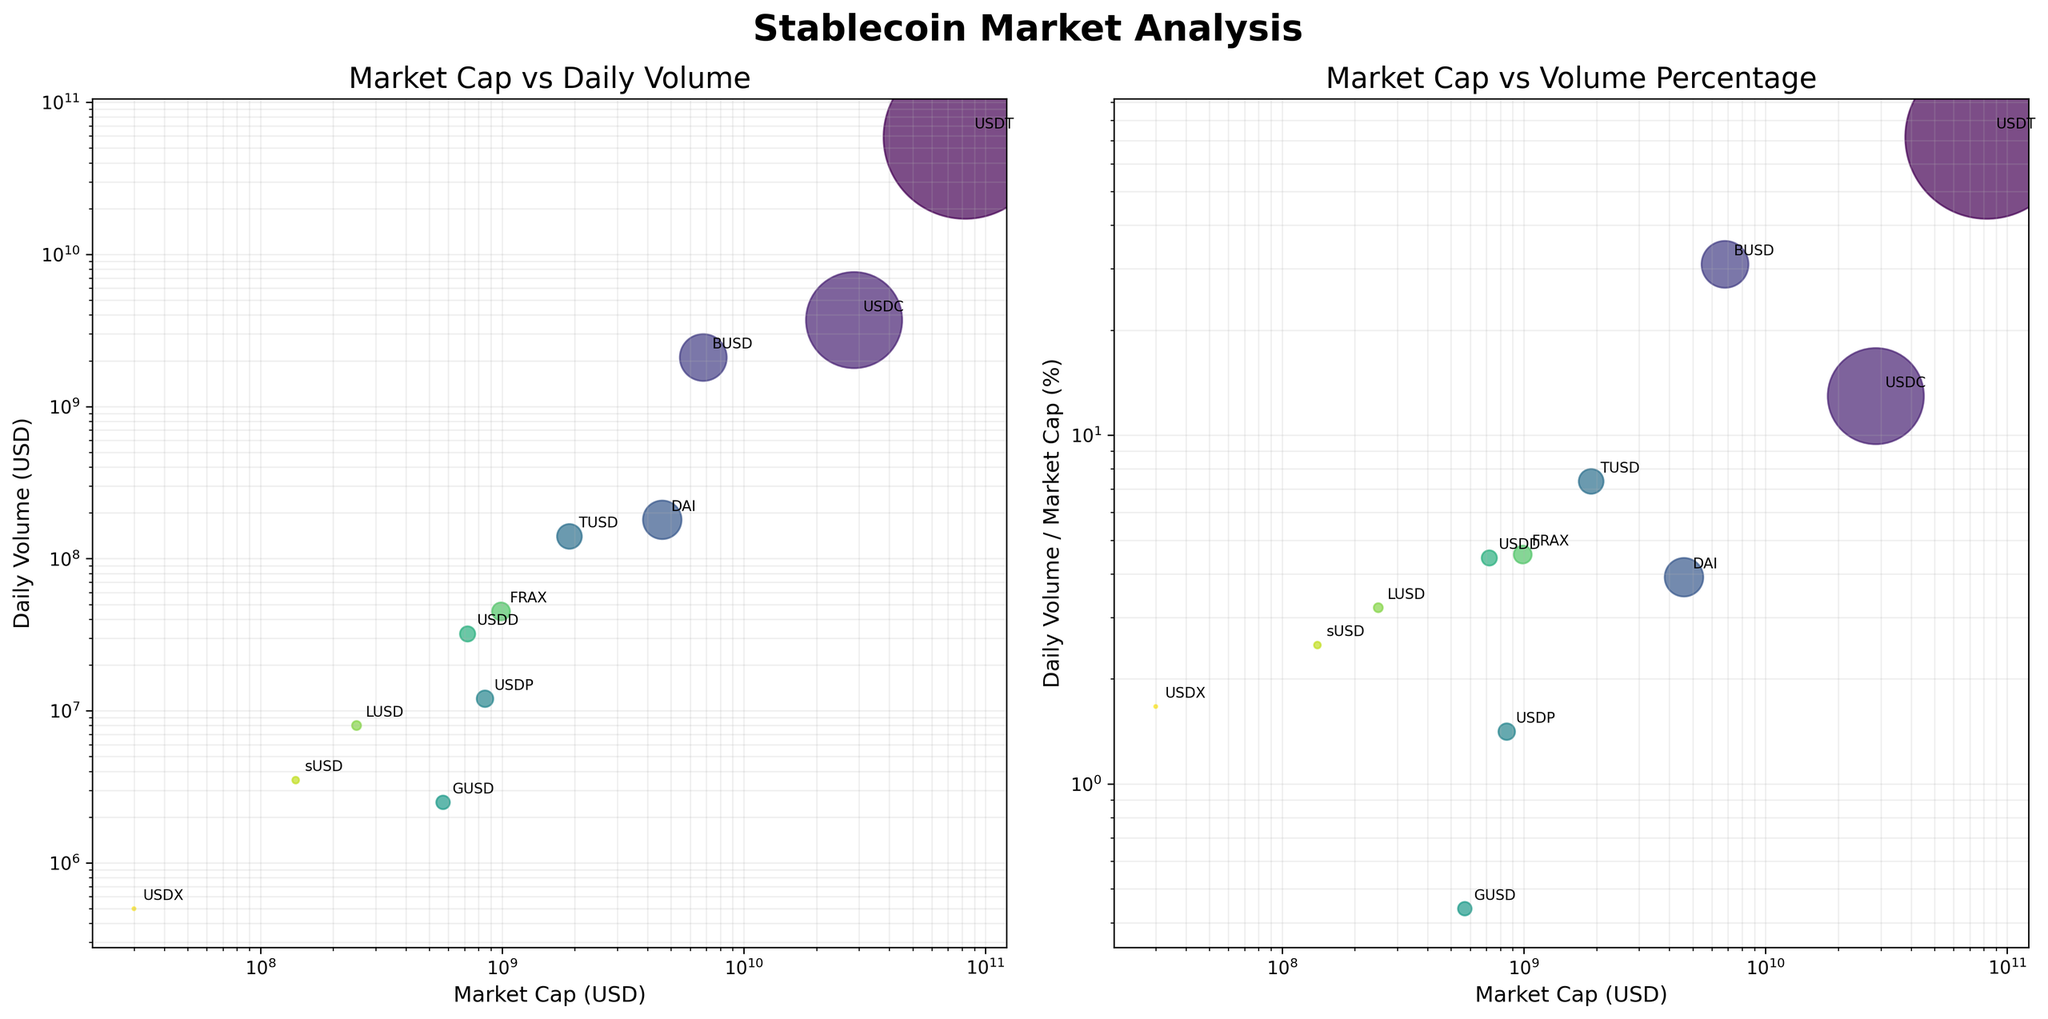What's the title of the figure in the plot? The title of the figure is typically displayed prominently at the top of the plot. For this figure, it is written in a bold, larger font compared to other text elements.
Answer: Stablecoin Market Analysis How are the axes labeled in the first subplot? The axes of the first subplot are labeled with text adjacent to the X and Y axes. The X-axis label reads "Market Cap (USD)" and the Y-axis label reads "Daily Volume (USD)".
Answer: Market Cap (USD) and Daily Volume (USD) Which stablecoin has the highest daily trading volume? By observing the data points on the Y-axis of the first subplot, the point corresponding to the highest value indicates the stablecoin. The label near the highest point will show which stablecoin it is.
Answer: USDT What is the market cap of the stablecoin labeled BUSD? By locating the point labeled "BUSD" in the first subplot and tracing it to the X-axis, we can see the market cap value.
Answer: 6.8 billion USD Which stablecoin has the highest percentage of daily volume relative to its market cap? In the second subplot, the stablecoin with the highest point on the Y-axis has the highest percentage of daily volume relative to its market cap.
Answer: USDT Which stablecoins have a market cap between 1 billion and 10 billion USD? Identify the points in both subplots that lie between 1 billion and 10 billion on the X-axis. The labels near these points indicate the stablecoins.
Answer: BUSD, DAI, TUSD, FRAX Which stablecoin has the lowest daily trading volume? By observing the data points on the Y-axis of the first subplot, the point corresponding to the lowest value indicates the stablecoin. The label near the lowest point will show which stablecoin it is.
Answer: USDX Of the stablecoins with a market cap above 1 billion USD, which has the lowest volume percentage? In the second subplot, locate the points representing market caps above 1 billion on the X-axis, then find the one with the lowest value on the Y-axis. The label near this point indicates the stablecoin.
Answer: USDC How does the daily trading volume of GUSD compare to that of sUSD? Look at both GUSD and sUSD points on the first subplot, then compare their positions on the Y-axis to determine which is higher or lower.
Answer: GUSD has higher daily trading volume than sUSD What is the daily volume to market cap ratio of FRAX? Locate FRAX in the second subplot. The Y-axis value for this point represents the daily volume to market cap percentage.
Answer: ~4.55% Which stablecoin has a significantly higher trading volume when compared to the others with similar market caps? In the first subplot, compare the heights of points (daily volume) that have similar X-axis values (market caps). Identify which point stands significantly higher.
Answer: USDT 